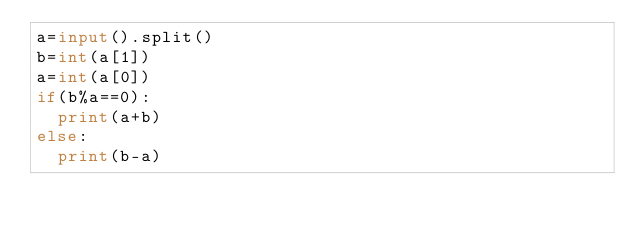<code> <loc_0><loc_0><loc_500><loc_500><_Python_>a=input().split()
b=int(a[1])
a=int(a[0])
if(b%a==0):
  print(a+b)
else:
  print(b-a)</code> 